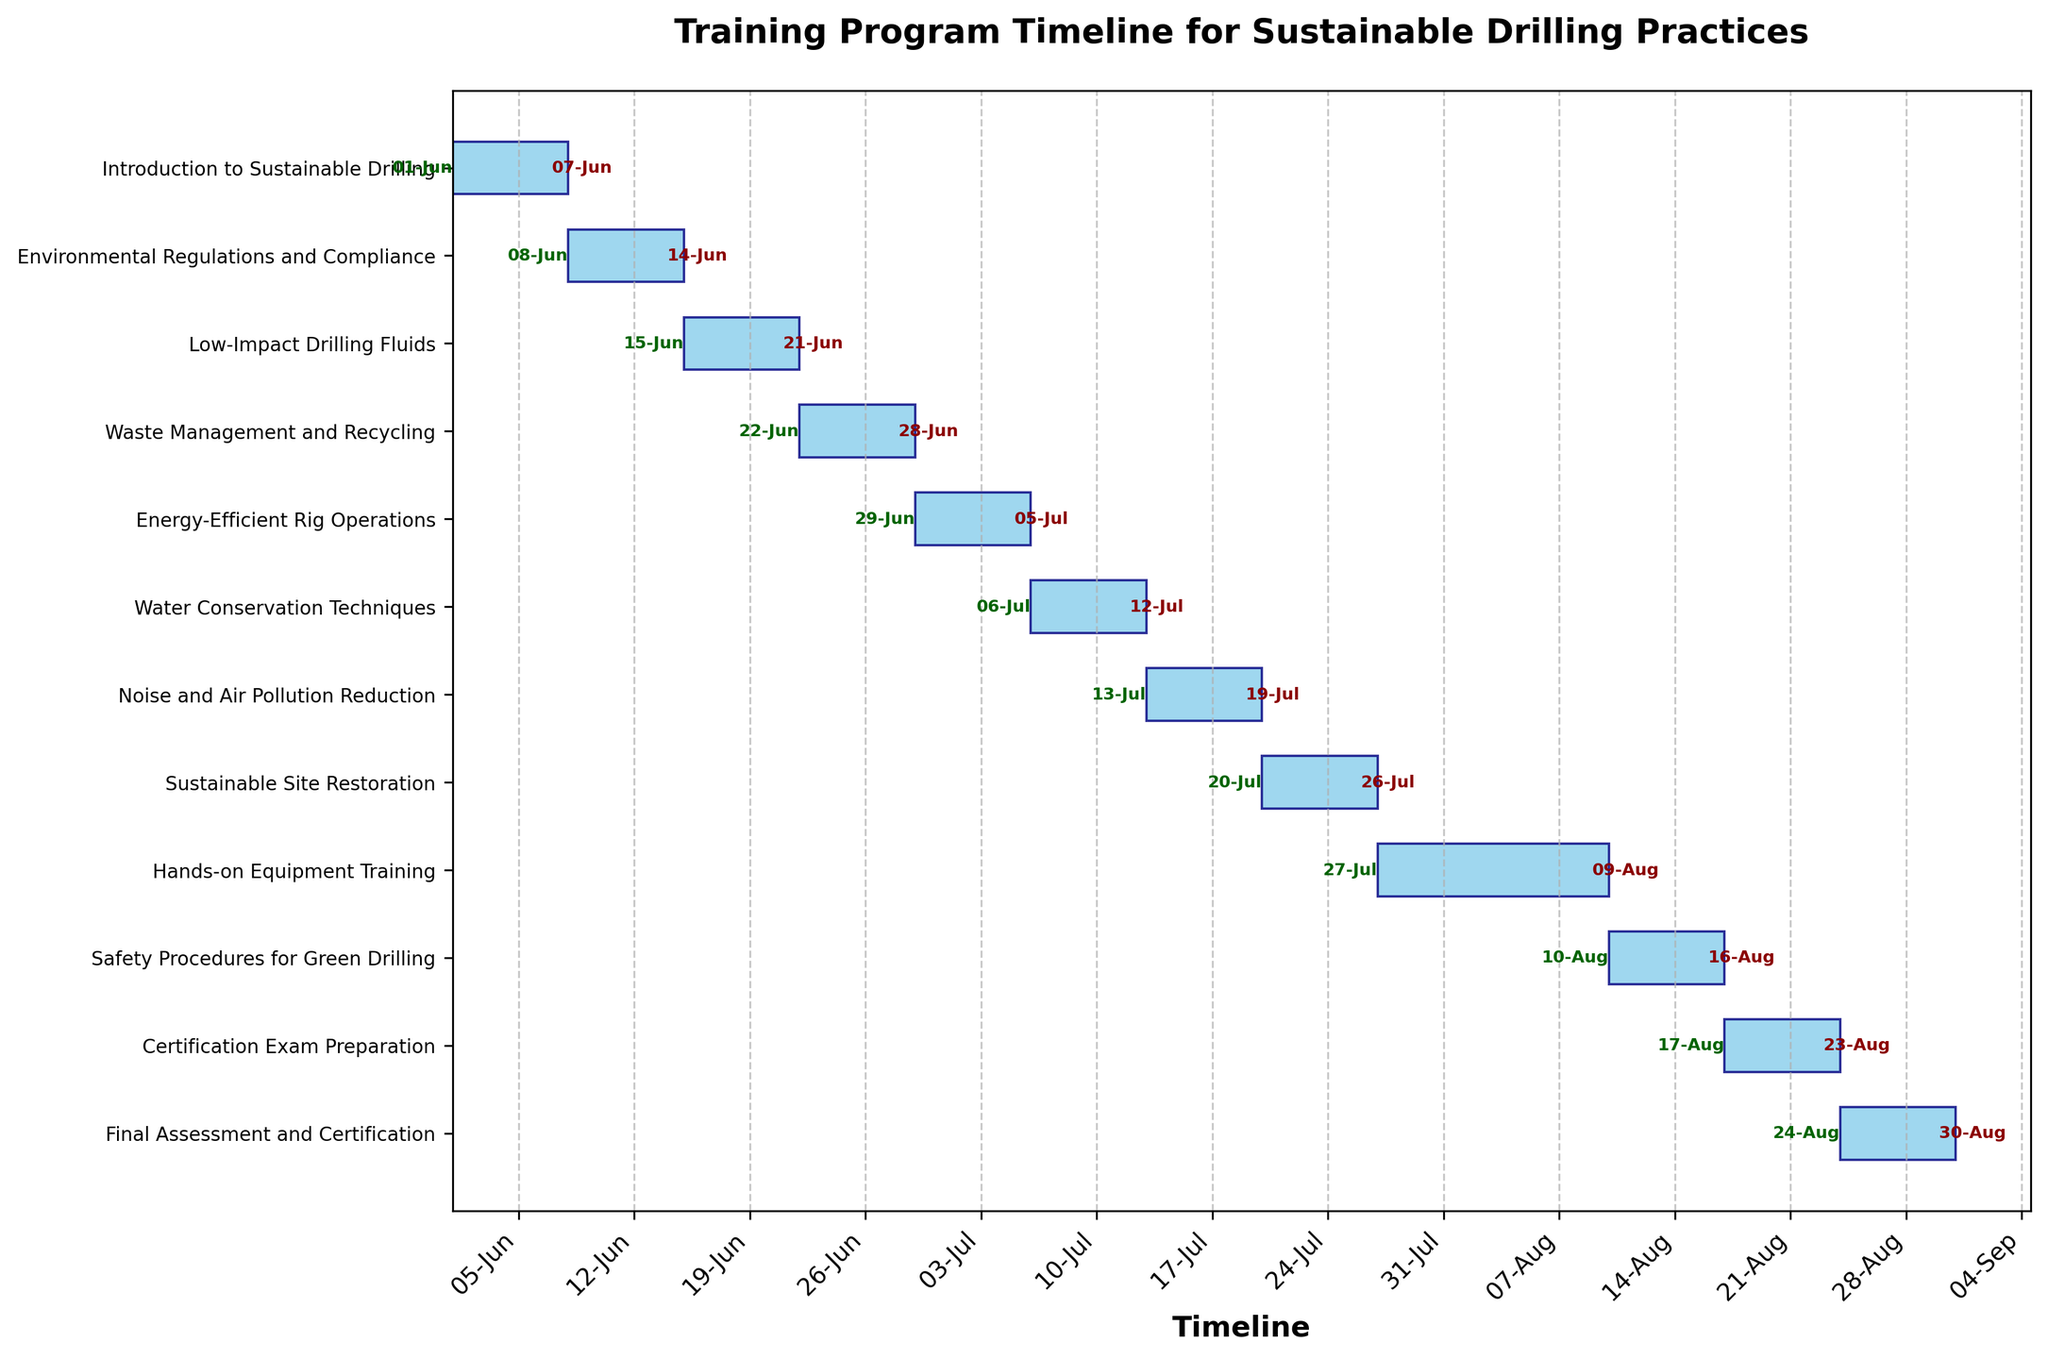Which task marks the start of the training program? The first task listed at the top of the Gantt Chart, aligned at position 0, is the starting task. It is also the earliest in terms of the date axis.
Answer: Introduction to Sustainable Drilling How many days does the "Waste Management and Recycling" module span? To determine the duration, subtract the start date from the end date and add one day (for inclusivity). June 28 minus June 22 plus one day equals 7 days.
Answer: 7 days What is the title of the figure? The title is usually placed at the top center of the figure, it directly summarizes the content of the Gantt Chart.
Answer: Training Program Timeline for Sustainable Drilling Practices Which two modules have the longest durations? By comparing the lengths of the bars, the longest ones can be identified visually. "Hands-on Equipment Training" and "Certification Exam Preparation" have the longest bars.
Answer: Hands-on Equipment Training and Certification Exam Preparation Do any tasks overlap in their timelines? In a Gantt Chart, overlapping tasks would be shown by bars starting before the previous task's bar ends. Here, all tasks are sequential without overlap.
Answer: No What task is scheduled to end on July 5th? The task ending on a specific date can be found by noting the dates at the end of the bars. The bar ending at July 5th corresponds to "Energy-Efficient Rig Operations."
Answer: Energy-Efficient Rig Operations By how many days does "Low-Impact Drilling Fluids" precede "Waste Management and Recycling"? Find the start dates of both tasks and subtract to find the difference. June 22 minus June 15 equals 7 days.
Answer: 7 days Which module starts immediately after "Environmental Regulations and Compliance"? By examining the order and start dates, the task starting right after June 14 is "Low-Impact Drilling Fluids," beginning on June 15.
Answer: Low-Impact Drilling Fluids What is the average duration of all tasks in the training program? Calculate the total duration by summing all individual durations and then divide by the number of tasks (12 in this case). Sum = 90. Average = 90/12 = 7.5
Answer: 7.5 days How does the duration of "Sustainable Site Restoration" compare to "Noise and Air Pollution Reduction"? Compare the lengths of the bars for both tasks. Both tasks span from July 20 to July 26 and from July 13 to July 19 respectively. Each has a duration of 7 days.
Answer: Same 